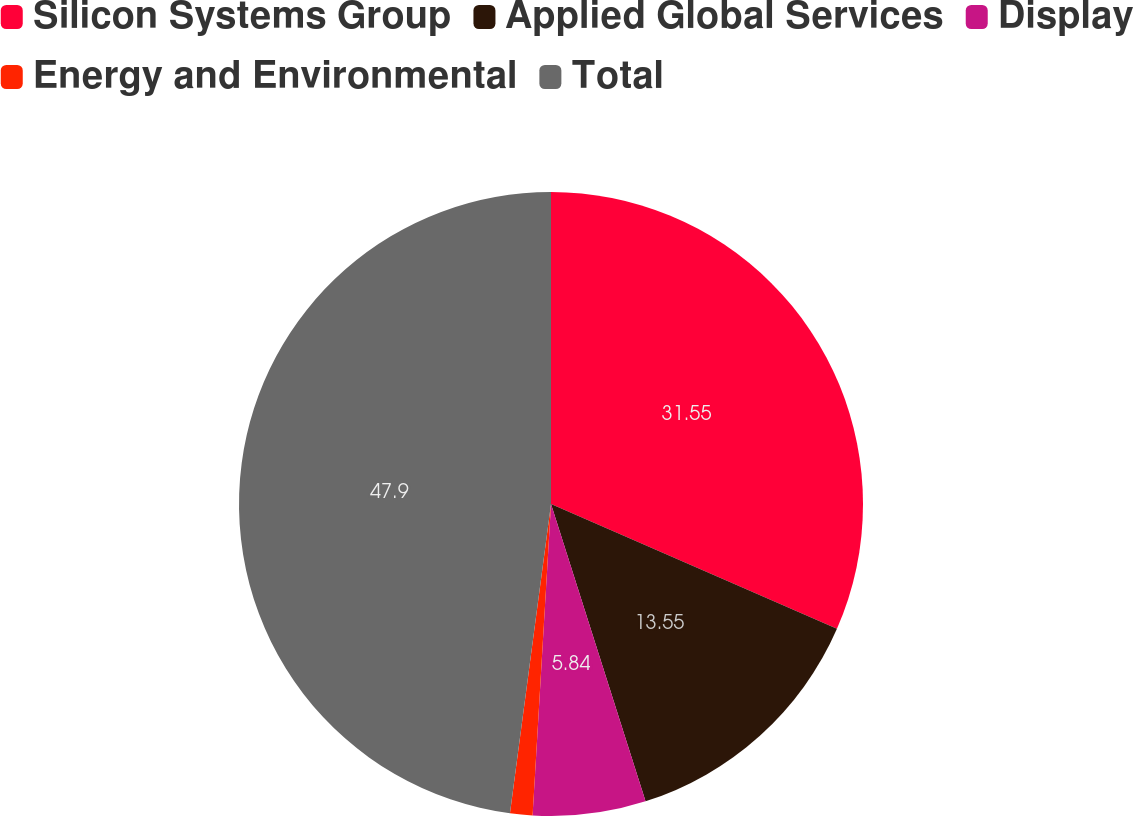Convert chart. <chart><loc_0><loc_0><loc_500><loc_500><pie_chart><fcel>Silicon Systems Group<fcel>Applied Global Services<fcel>Display<fcel>Energy and Environmental<fcel>Total<nl><fcel>31.55%<fcel>13.55%<fcel>5.84%<fcel>1.16%<fcel>47.9%<nl></chart> 